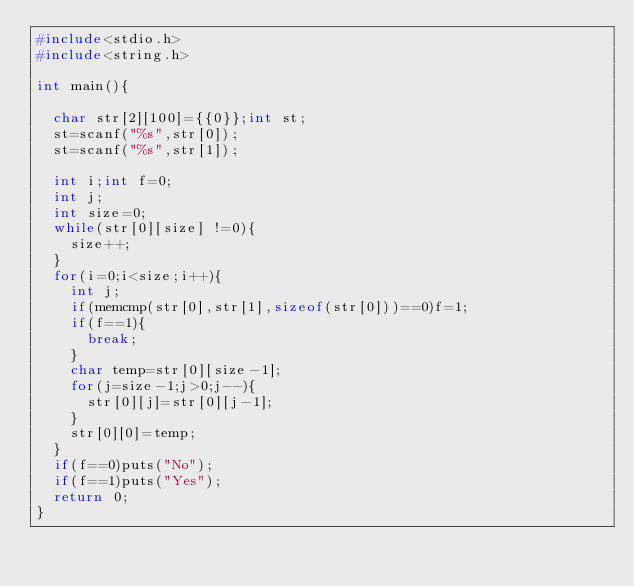<code> <loc_0><loc_0><loc_500><loc_500><_C_>#include<stdio.h>
#include<string.h>

int main(){

  char str[2][100]={{0}};int st;
  st=scanf("%s",str[0]);
  st=scanf("%s",str[1]);

  int i;int f=0;
  int j;
  int size=0;
  while(str[0][size] !=0){
    size++;
  }
  for(i=0;i<size;i++){
    int j;
    if(memcmp(str[0],str[1],sizeof(str[0]))==0)f=1;
    if(f==1){
      break;
    }
    char temp=str[0][size-1];
    for(j=size-1;j>0;j--){
      str[0][j]=str[0][j-1];
    }
    str[0][0]=temp;
  }
  if(f==0)puts("No");
  if(f==1)puts("Yes");
  return 0;
}
</code> 